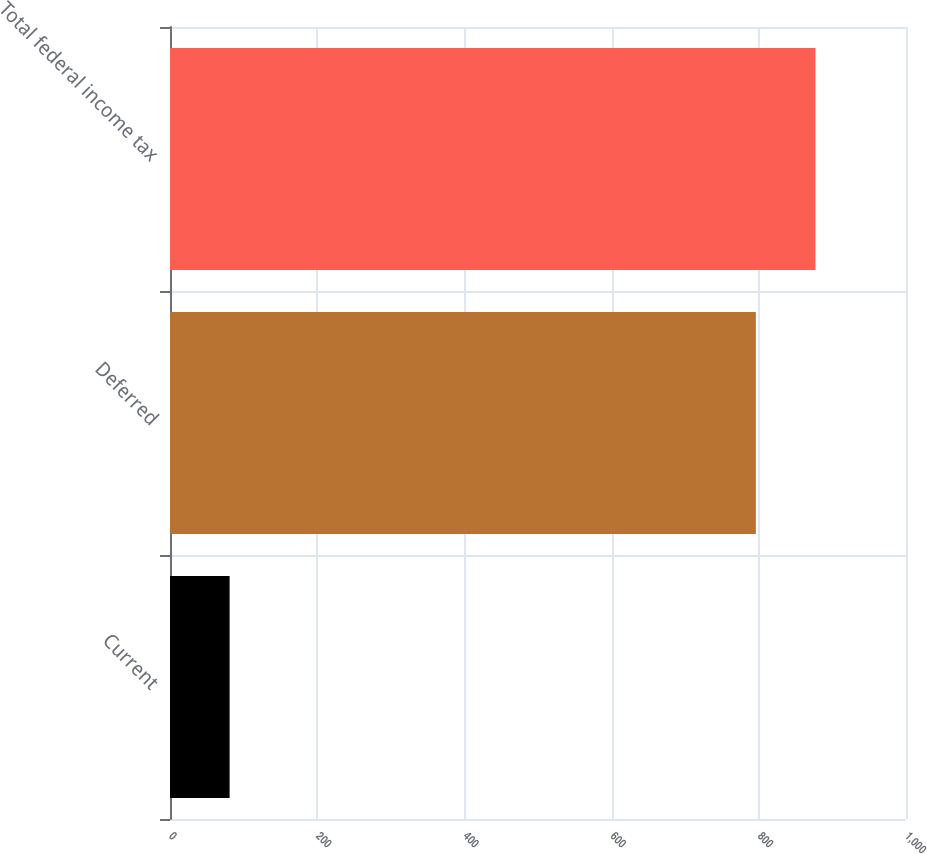<chart> <loc_0><loc_0><loc_500><loc_500><bar_chart><fcel>Current<fcel>Deferred<fcel>Total federal income tax<nl><fcel>81<fcel>796<fcel>877<nl></chart> 